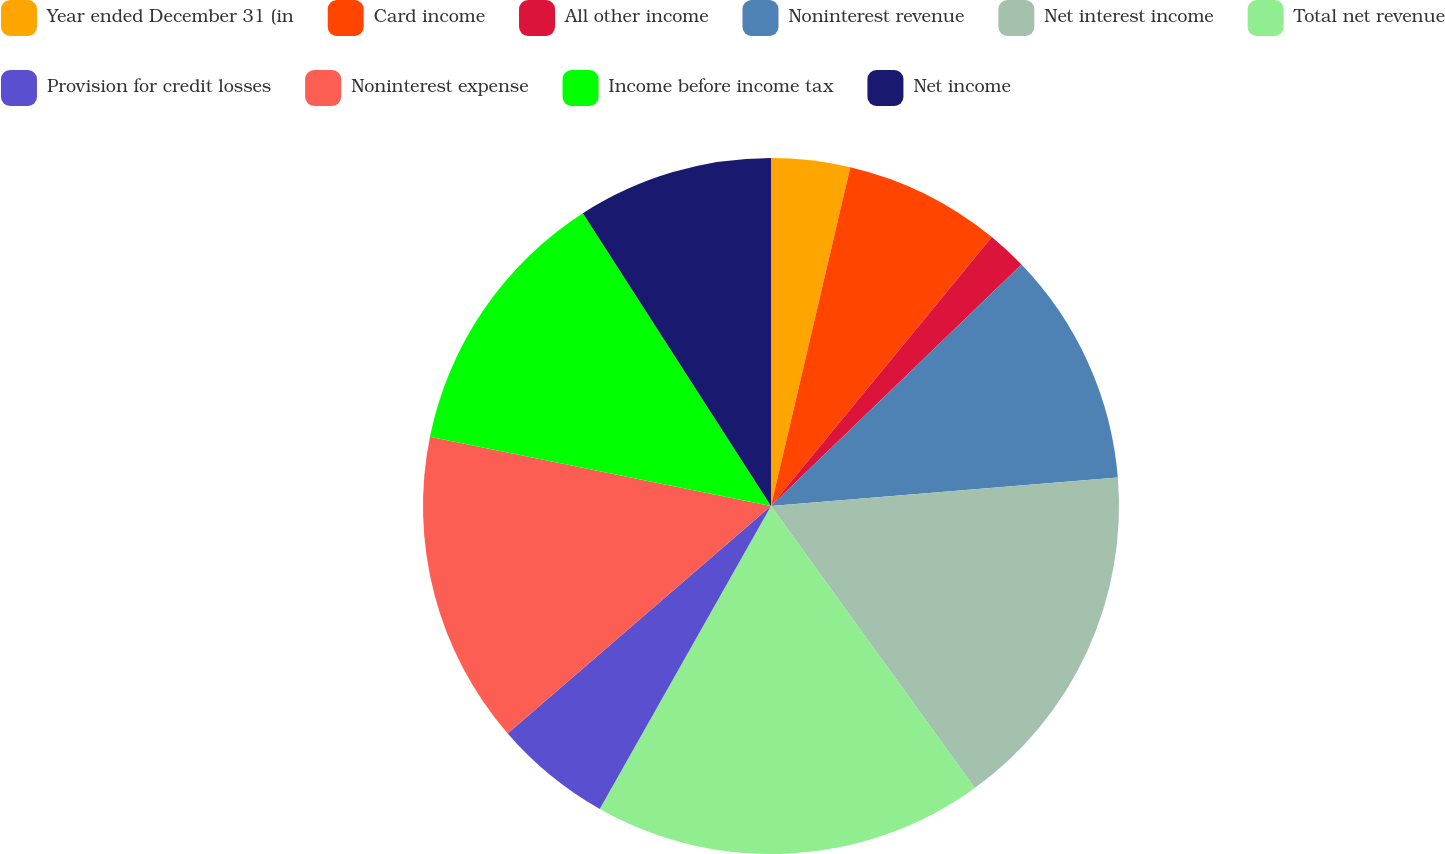<chart> <loc_0><loc_0><loc_500><loc_500><pie_chart><fcel>Year ended December 31 (in<fcel>Card income<fcel>All other income<fcel>Noninterest revenue<fcel>Net interest income<fcel>Total net revenue<fcel>Provision for credit losses<fcel>Noninterest expense<fcel>Income before income tax<fcel>Net income<nl><fcel>3.66%<fcel>7.28%<fcel>1.85%<fcel>10.91%<fcel>16.34%<fcel>18.15%<fcel>5.47%<fcel>14.53%<fcel>12.72%<fcel>9.09%<nl></chart> 